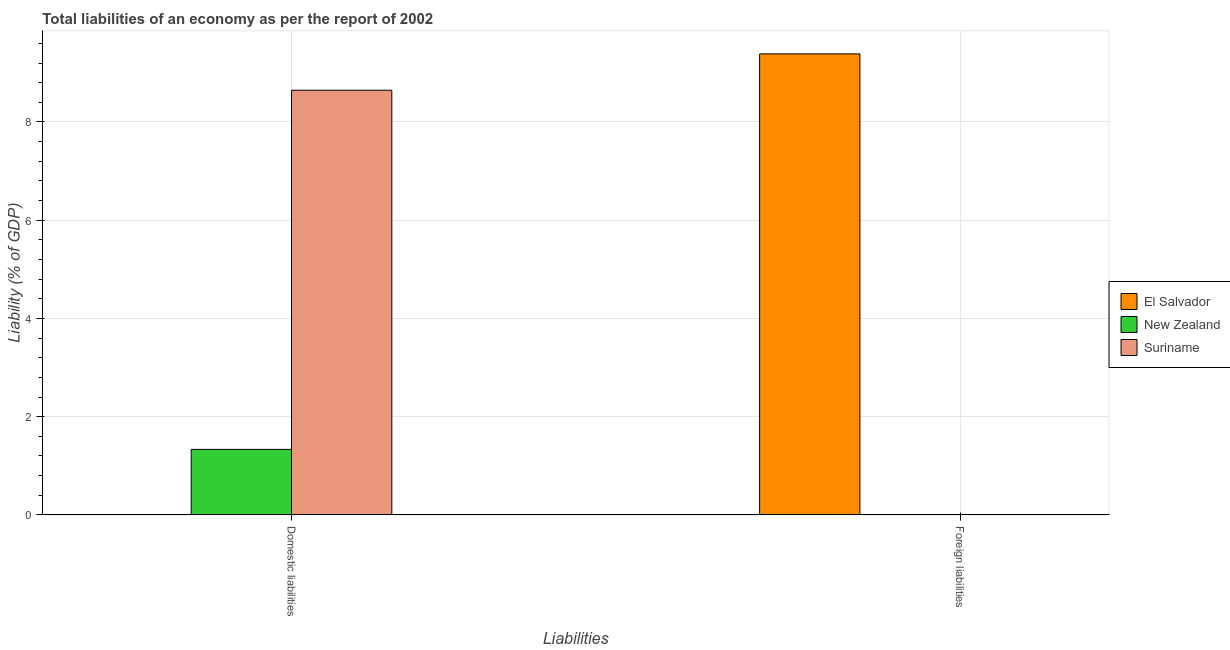Are the number of bars per tick equal to the number of legend labels?
Offer a terse response. No. Are the number of bars on each tick of the X-axis equal?
Offer a terse response. No. What is the label of the 1st group of bars from the left?
Your answer should be compact. Domestic liabilities. Across all countries, what is the maximum incurrence of domestic liabilities?
Your answer should be compact. 8.65. Across all countries, what is the minimum incurrence of domestic liabilities?
Make the answer very short. 0. In which country was the incurrence of domestic liabilities maximum?
Provide a short and direct response. Suriname. What is the total incurrence of domestic liabilities in the graph?
Provide a succinct answer. 9.98. What is the difference between the incurrence of domestic liabilities in Suriname and that in New Zealand?
Make the answer very short. 7.31. What is the difference between the incurrence of domestic liabilities in Suriname and the incurrence of foreign liabilities in New Zealand?
Your answer should be compact. 8.65. What is the average incurrence of domestic liabilities per country?
Give a very brief answer. 3.33. What is the ratio of the incurrence of domestic liabilities in Suriname to that in New Zealand?
Provide a short and direct response. 6.48. Are the values on the major ticks of Y-axis written in scientific E-notation?
Ensure brevity in your answer.  No. Does the graph contain any zero values?
Make the answer very short. Yes. Does the graph contain grids?
Provide a succinct answer. Yes. Where does the legend appear in the graph?
Offer a very short reply. Center right. How many legend labels are there?
Provide a succinct answer. 3. How are the legend labels stacked?
Your answer should be very brief. Vertical. What is the title of the graph?
Offer a terse response. Total liabilities of an economy as per the report of 2002. What is the label or title of the X-axis?
Offer a terse response. Liabilities. What is the label or title of the Y-axis?
Your response must be concise. Liability (% of GDP). What is the Liability (% of GDP) of New Zealand in Domestic liabilities?
Offer a terse response. 1.33. What is the Liability (% of GDP) in Suriname in Domestic liabilities?
Your response must be concise. 8.65. What is the Liability (% of GDP) of El Salvador in Foreign liabilities?
Your response must be concise. 9.39. Across all Liabilities, what is the maximum Liability (% of GDP) of El Salvador?
Your response must be concise. 9.39. Across all Liabilities, what is the maximum Liability (% of GDP) of New Zealand?
Provide a short and direct response. 1.33. Across all Liabilities, what is the maximum Liability (% of GDP) in Suriname?
Your answer should be very brief. 8.65. Across all Liabilities, what is the minimum Liability (% of GDP) in New Zealand?
Keep it short and to the point. 0. What is the total Liability (% of GDP) of El Salvador in the graph?
Provide a short and direct response. 9.39. What is the total Liability (% of GDP) in New Zealand in the graph?
Offer a very short reply. 1.33. What is the total Liability (% of GDP) in Suriname in the graph?
Your answer should be very brief. 8.65. What is the average Liability (% of GDP) of El Salvador per Liabilities?
Your response must be concise. 4.69. What is the average Liability (% of GDP) of New Zealand per Liabilities?
Provide a succinct answer. 0.67. What is the average Liability (% of GDP) of Suriname per Liabilities?
Your answer should be compact. 4.32. What is the difference between the Liability (% of GDP) of New Zealand and Liability (% of GDP) of Suriname in Domestic liabilities?
Your answer should be very brief. -7.31. What is the difference between the highest and the lowest Liability (% of GDP) in El Salvador?
Your answer should be compact. 9.39. What is the difference between the highest and the lowest Liability (% of GDP) in New Zealand?
Keep it short and to the point. 1.33. What is the difference between the highest and the lowest Liability (% of GDP) in Suriname?
Keep it short and to the point. 8.65. 